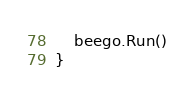<code> <loc_0><loc_0><loc_500><loc_500><_Go_>
	beego.Run()
}
</code> 